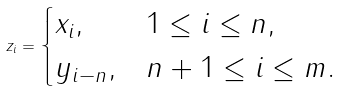Convert formula to latex. <formula><loc_0><loc_0><loc_500><loc_500>z _ { i } = \begin{cases} x _ { i } , & 1 \leq i \leq n , \\ y _ { i - n } , & n + 1 \leq i \leq m . \end{cases}</formula> 